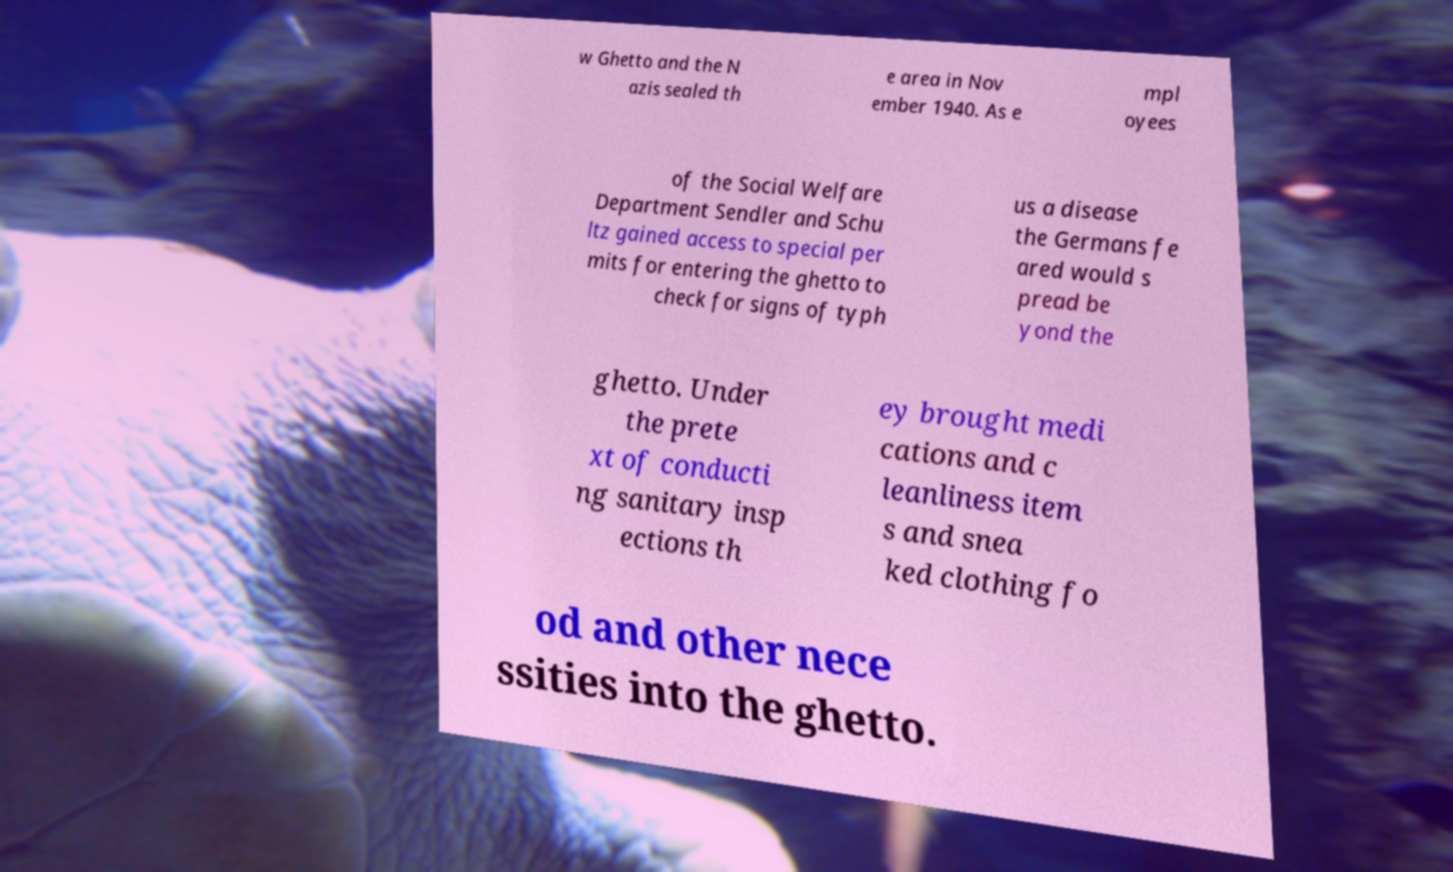For documentation purposes, I need the text within this image transcribed. Could you provide that? w Ghetto and the N azis sealed th e area in Nov ember 1940. As e mpl oyees of the Social Welfare Department Sendler and Schu ltz gained access to special per mits for entering the ghetto to check for signs of typh us a disease the Germans fe ared would s pread be yond the ghetto. Under the prete xt of conducti ng sanitary insp ections th ey brought medi cations and c leanliness item s and snea ked clothing fo od and other nece ssities into the ghetto. 